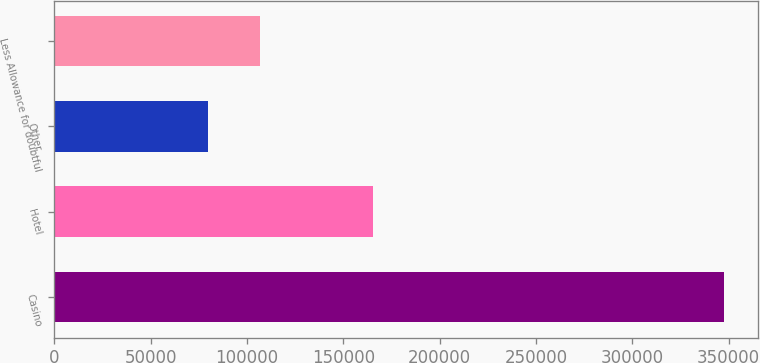Convert chart to OTSL. <chart><loc_0><loc_0><loc_500><loc_500><bar_chart><fcel>Casino<fcel>Hotel<fcel>Other<fcel>Less Allowance for doubtful<nl><fcel>347679<fcel>165410<fcel>79848<fcel>106631<nl></chart> 